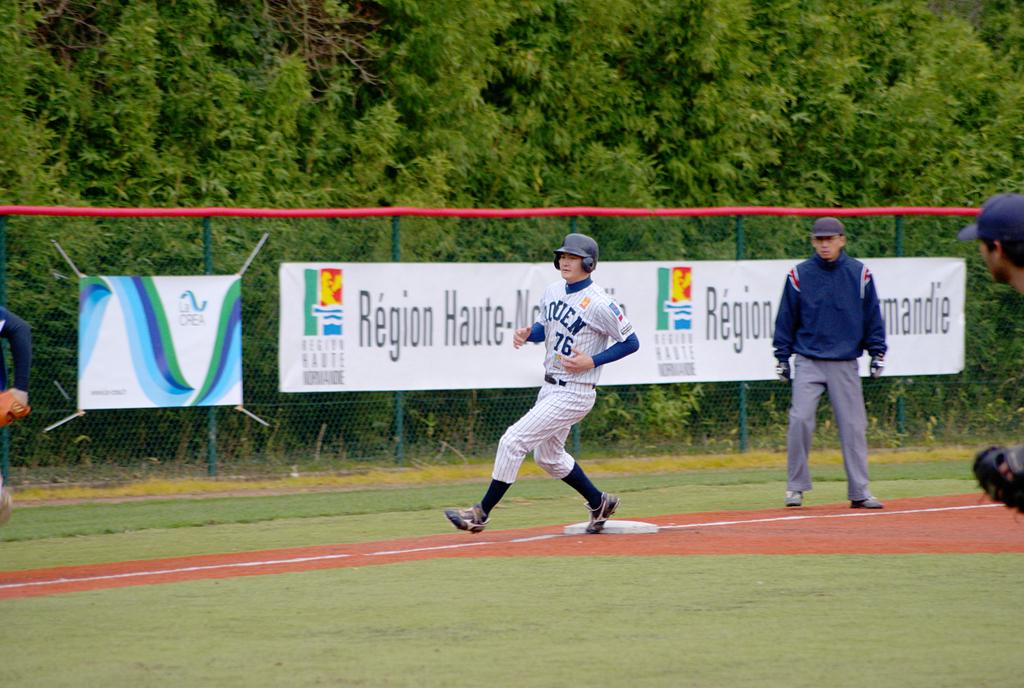What company is advertised on the far left banner?
Your answer should be very brief. La crea. 